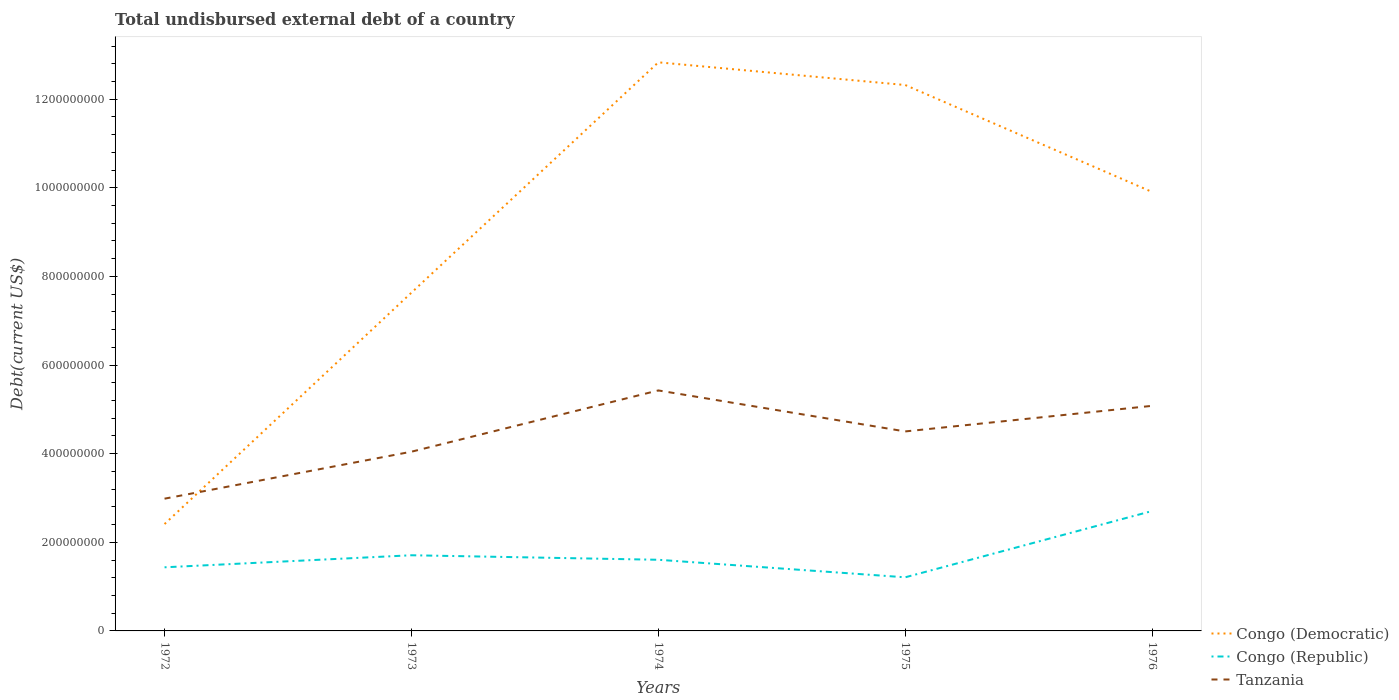How many different coloured lines are there?
Your answer should be compact. 3. Does the line corresponding to Congo (Republic) intersect with the line corresponding to Congo (Democratic)?
Ensure brevity in your answer.  No. Across all years, what is the maximum total undisbursed external debt in Tanzania?
Provide a short and direct response. 2.98e+08. In which year was the total undisbursed external debt in Tanzania maximum?
Your answer should be very brief. 1972. What is the total total undisbursed external debt in Congo (Democratic) in the graph?
Give a very brief answer. -1.04e+09. What is the difference between the highest and the second highest total undisbursed external debt in Tanzania?
Give a very brief answer. 2.44e+08. What is the difference between the highest and the lowest total undisbursed external debt in Congo (Republic)?
Offer a very short reply. 1. Is the total undisbursed external debt in Congo (Democratic) strictly greater than the total undisbursed external debt in Congo (Republic) over the years?
Your response must be concise. No. How many lines are there?
Offer a terse response. 3. Are the values on the major ticks of Y-axis written in scientific E-notation?
Ensure brevity in your answer.  No. Does the graph contain any zero values?
Offer a terse response. No. Where does the legend appear in the graph?
Provide a short and direct response. Bottom right. How many legend labels are there?
Keep it short and to the point. 3. How are the legend labels stacked?
Your answer should be compact. Vertical. What is the title of the graph?
Keep it short and to the point. Total undisbursed external debt of a country. What is the label or title of the X-axis?
Offer a terse response. Years. What is the label or title of the Y-axis?
Provide a succinct answer. Debt(current US$). What is the Debt(current US$) of Congo (Democratic) in 1972?
Your answer should be compact. 2.41e+08. What is the Debt(current US$) in Congo (Republic) in 1972?
Give a very brief answer. 1.44e+08. What is the Debt(current US$) of Tanzania in 1972?
Your answer should be compact. 2.98e+08. What is the Debt(current US$) in Congo (Democratic) in 1973?
Provide a short and direct response. 7.63e+08. What is the Debt(current US$) in Congo (Republic) in 1973?
Offer a terse response. 1.71e+08. What is the Debt(current US$) of Tanzania in 1973?
Offer a terse response. 4.04e+08. What is the Debt(current US$) in Congo (Democratic) in 1974?
Give a very brief answer. 1.28e+09. What is the Debt(current US$) of Congo (Republic) in 1974?
Offer a terse response. 1.61e+08. What is the Debt(current US$) in Tanzania in 1974?
Your answer should be very brief. 5.43e+08. What is the Debt(current US$) of Congo (Democratic) in 1975?
Provide a short and direct response. 1.23e+09. What is the Debt(current US$) in Congo (Republic) in 1975?
Provide a short and direct response. 1.21e+08. What is the Debt(current US$) in Tanzania in 1975?
Provide a short and direct response. 4.50e+08. What is the Debt(current US$) of Congo (Democratic) in 1976?
Offer a very short reply. 9.91e+08. What is the Debt(current US$) of Congo (Republic) in 1976?
Provide a succinct answer. 2.71e+08. What is the Debt(current US$) of Tanzania in 1976?
Keep it short and to the point. 5.08e+08. Across all years, what is the maximum Debt(current US$) of Congo (Democratic)?
Offer a very short reply. 1.28e+09. Across all years, what is the maximum Debt(current US$) in Congo (Republic)?
Provide a succinct answer. 2.71e+08. Across all years, what is the maximum Debt(current US$) in Tanzania?
Ensure brevity in your answer.  5.43e+08. Across all years, what is the minimum Debt(current US$) of Congo (Democratic)?
Give a very brief answer. 2.41e+08. Across all years, what is the minimum Debt(current US$) in Congo (Republic)?
Provide a succinct answer. 1.21e+08. Across all years, what is the minimum Debt(current US$) of Tanzania?
Make the answer very short. 2.98e+08. What is the total Debt(current US$) of Congo (Democratic) in the graph?
Give a very brief answer. 4.51e+09. What is the total Debt(current US$) of Congo (Republic) in the graph?
Give a very brief answer. 8.67e+08. What is the total Debt(current US$) of Tanzania in the graph?
Keep it short and to the point. 2.20e+09. What is the difference between the Debt(current US$) in Congo (Democratic) in 1972 and that in 1973?
Keep it short and to the point. -5.22e+08. What is the difference between the Debt(current US$) of Congo (Republic) in 1972 and that in 1973?
Give a very brief answer. -2.72e+07. What is the difference between the Debt(current US$) in Tanzania in 1972 and that in 1973?
Offer a terse response. -1.06e+08. What is the difference between the Debt(current US$) of Congo (Democratic) in 1972 and that in 1974?
Your answer should be compact. -1.04e+09. What is the difference between the Debt(current US$) of Congo (Republic) in 1972 and that in 1974?
Provide a short and direct response. -1.70e+07. What is the difference between the Debt(current US$) of Tanzania in 1972 and that in 1974?
Ensure brevity in your answer.  -2.44e+08. What is the difference between the Debt(current US$) in Congo (Democratic) in 1972 and that in 1975?
Make the answer very short. -9.91e+08. What is the difference between the Debt(current US$) in Congo (Republic) in 1972 and that in 1975?
Offer a very short reply. 2.26e+07. What is the difference between the Debt(current US$) in Tanzania in 1972 and that in 1975?
Offer a very short reply. -1.52e+08. What is the difference between the Debt(current US$) of Congo (Democratic) in 1972 and that in 1976?
Your response must be concise. -7.49e+08. What is the difference between the Debt(current US$) of Congo (Republic) in 1972 and that in 1976?
Keep it short and to the point. -1.27e+08. What is the difference between the Debt(current US$) of Tanzania in 1972 and that in 1976?
Give a very brief answer. -2.10e+08. What is the difference between the Debt(current US$) in Congo (Democratic) in 1973 and that in 1974?
Offer a terse response. -5.20e+08. What is the difference between the Debt(current US$) in Congo (Republic) in 1973 and that in 1974?
Provide a short and direct response. 1.02e+07. What is the difference between the Debt(current US$) of Tanzania in 1973 and that in 1974?
Your answer should be very brief. -1.38e+08. What is the difference between the Debt(current US$) in Congo (Democratic) in 1973 and that in 1975?
Make the answer very short. -4.69e+08. What is the difference between the Debt(current US$) in Congo (Republic) in 1973 and that in 1975?
Make the answer very short. 4.97e+07. What is the difference between the Debt(current US$) in Tanzania in 1973 and that in 1975?
Your answer should be very brief. -4.58e+07. What is the difference between the Debt(current US$) of Congo (Democratic) in 1973 and that in 1976?
Offer a very short reply. -2.27e+08. What is the difference between the Debt(current US$) in Congo (Republic) in 1973 and that in 1976?
Offer a terse response. -9.98e+07. What is the difference between the Debt(current US$) of Tanzania in 1973 and that in 1976?
Your response must be concise. -1.04e+08. What is the difference between the Debt(current US$) in Congo (Democratic) in 1974 and that in 1975?
Keep it short and to the point. 5.12e+07. What is the difference between the Debt(current US$) in Congo (Republic) in 1974 and that in 1975?
Give a very brief answer. 3.96e+07. What is the difference between the Debt(current US$) in Tanzania in 1974 and that in 1975?
Ensure brevity in your answer.  9.25e+07. What is the difference between the Debt(current US$) in Congo (Democratic) in 1974 and that in 1976?
Give a very brief answer. 2.93e+08. What is the difference between the Debt(current US$) in Congo (Republic) in 1974 and that in 1976?
Provide a short and direct response. -1.10e+08. What is the difference between the Debt(current US$) in Tanzania in 1974 and that in 1976?
Give a very brief answer. 3.48e+07. What is the difference between the Debt(current US$) in Congo (Democratic) in 1975 and that in 1976?
Give a very brief answer. 2.41e+08. What is the difference between the Debt(current US$) in Congo (Republic) in 1975 and that in 1976?
Make the answer very short. -1.50e+08. What is the difference between the Debt(current US$) of Tanzania in 1975 and that in 1976?
Offer a terse response. -5.78e+07. What is the difference between the Debt(current US$) in Congo (Democratic) in 1972 and the Debt(current US$) in Congo (Republic) in 1973?
Give a very brief answer. 7.04e+07. What is the difference between the Debt(current US$) of Congo (Democratic) in 1972 and the Debt(current US$) of Tanzania in 1973?
Keep it short and to the point. -1.63e+08. What is the difference between the Debt(current US$) of Congo (Republic) in 1972 and the Debt(current US$) of Tanzania in 1973?
Your response must be concise. -2.61e+08. What is the difference between the Debt(current US$) of Congo (Democratic) in 1972 and the Debt(current US$) of Congo (Republic) in 1974?
Your response must be concise. 8.06e+07. What is the difference between the Debt(current US$) in Congo (Democratic) in 1972 and the Debt(current US$) in Tanzania in 1974?
Your response must be concise. -3.02e+08. What is the difference between the Debt(current US$) of Congo (Republic) in 1972 and the Debt(current US$) of Tanzania in 1974?
Offer a terse response. -3.99e+08. What is the difference between the Debt(current US$) in Congo (Democratic) in 1972 and the Debt(current US$) in Congo (Republic) in 1975?
Provide a short and direct response. 1.20e+08. What is the difference between the Debt(current US$) in Congo (Democratic) in 1972 and the Debt(current US$) in Tanzania in 1975?
Give a very brief answer. -2.09e+08. What is the difference between the Debt(current US$) in Congo (Republic) in 1972 and the Debt(current US$) in Tanzania in 1975?
Your answer should be very brief. -3.07e+08. What is the difference between the Debt(current US$) of Congo (Democratic) in 1972 and the Debt(current US$) of Congo (Republic) in 1976?
Ensure brevity in your answer.  -2.94e+07. What is the difference between the Debt(current US$) of Congo (Democratic) in 1972 and the Debt(current US$) of Tanzania in 1976?
Your response must be concise. -2.67e+08. What is the difference between the Debt(current US$) of Congo (Republic) in 1972 and the Debt(current US$) of Tanzania in 1976?
Ensure brevity in your answer.  -3.64e+08. What is the difference between the Debt(current US$) of Congo (Democratic) in 1973 and the Debt(current US$) of Congo (Republic) in 1974?
Offer a very short reply. 6.03e+08. What is the difference between the Debt(current US$) in Congo (Democratic) in 1973 and the Debt(current US$) in Tanzania in 1974?
Offer a very short reply. 2.21e+08. What is the difference between the Debt(current US$) of Congo (Republic) in 1973 and the Debt(current US$) of Tanzania in 1974?
Make the answer very short. -3.72e+08. What is the difference between the Debt(current US$) in Congo (Democratic) in 1973 and the Debt(current US$) in Congo (Republic) in 1975?
Your answer should be very brief. 6.42e+08. What is the difference between the Debt(current US$) of Congo (Democratic) in 1973 and the Debt(current US$) of Tanzania in 1975?
Ensure brevity in your answer.  3.13e+08. What is the difference between the Debt(current US$) of Congo (Republic) in 1973 and the Debt(current US$) of Tanzania in 1975?
Offer a terse response. -2.79e+08. What is the difference between the Debt(current US$) in Congo (Democratic) in 1973 and the Debt(current US$) in Congo (Republic) in 1976?
Provide a succinct answer. 4.93e+08. What is the difference between the Debt(current US$) in Congo (Democratic) in 1973 and the Debt(current US$) in Tanzania in 1976?
Offer a terse response. 2.55e+08. What is the difference between the Debt(current US$) in Congo (Republic) in 1973 and the Debt(current US$) in Tanzania in 1976?
Offer a terse response. -3.37e+08. What is the difference between the Debt(current US$) of Congo (Democratic) in 1974 and the Debt(current US$) of Congo (Republic) in 1975?
Your response must be concise. 1.16e+09. What is the difference between the Debt(current US$) in Congo (Democratic) in 1974 and the Debt(current US$) in Tanzania in 1975?
Keep it short and to the point. 8.33e+08. What is the difference between the Debt(current US$) of Congo (Republic) in 1974 and the Debt(current US$) of Tanzania in 1975?
Keep it short and to the point. -2.90e+08. What is the difference between the Debt(current US$) in Congo (Democratic) in 1974 and the Debt(current US$) in Congo (Republic) in 1976?
Your answer should be compact. 1.01e+09. What is the difference between the Debt(current US$) of Congo (Democratic) in 1974 and the Debt(current US$) of Tanzania in 1976?
Your answer should be compact. 7.75e+08. What is the difference between the Debt(current US$) in Congo (Republic) in 1974 and the Debt(current US$) in Tanzania in 1976?
Your answer should be compact. -3.47e+08. What is the difference between the Debt(current US$) of Congo (Democratic) in 1975 and the Debt(current US$) of Congo (Republic) in 1976?
Provide a short and direct response. 9.61e+08. What is the difference between the Debt(current US$) of Congo (Democratic) in 1975 and the Debt(current US$) of Tanzania in 1976?
Ensure brevity in your answer.  7.24e+08. What is the difference between the Debt(current US$) in Congo (Republic) in 1975 and the Debt(current US$) in Tanzania in 1976?
Offer a terse response. -3.87e+08. What is the average Debt(current US$) in Congo (Democratic) per year?
Keep it short and to the point. 9.02e+08. What is the average Debt(current US$) in Congo (Republic) per year?
Your answer should be very brief. 1.73e+08. What is the average Debt(current US$) of Tanzania per year?
Your response must be concise. 4.41e+08. In the year 1972, what is the difference between the Debt(current US$) in Congo (Democratic) and Debt(current US$) in Congo (Republic)?
Offer a very short reply. 9.76e+07. In the year 1972, what is the difference between the Debt(current US$) of Congo (Democratic) and Debt(current US$) of Tanzania?
Ensure brevity in your answer.  -5.73e+07. In the year 1972, what is the difference between the Debt(current US$) in Congo (Republic) and Debt(current US$) in Tanzania?
Your answer should be compact. -1.55e+08. In the year 1973, what is the difference between the Debt(current US$) in Congo (Democratic) and Debt(current US$) in Congo (Republic)?
Make the answer very short. 5.93e+08. In the year 1973, what is the difference between the Debt(current US$) of Congo (Democratic) and Debt(current US$) of Tanzania?
Offer a very short reply. 3.59e+08. In the year 1973, what is the difference between the Debt(current US$) in Congo (Republic) and Debt(current US$) in Tanzania?
Your answer should be compact. -2.34e+08. In the year 1974, what is the difference between the Debt(current US$) of Congo (Democratic) and Debt(current US$) of Congo (Republic)?
Give a very brief answer. 1.12e+09. In the year 1974, what is the difference between the Debt(current US$) in Congo (Democratic) and Debt(current US$) in Tanzania?
Give a very brief answer. 7.40e+08. In the year 1974, what is the difference between the Debt(current US$) of Congo (Republic) and Debt(current US$) of Tanzania?
Make the answer very short. -3.82e+08. In the year 1975, what is the difference between the Debt(current US$) in Congo (Democratic) and Debt(current US$) in Congo (Republic)?
Provide a short and direct response. 1.11e+09. In the year 1975, what is the difference between the Debt(current US$) in Congo (Democratic) and Debt(current US$) in Tanzania?
Your response must be concise. 7.82e+08. In the year 1975, what is the difference between the Debt(current US$) of Congo (Republic) and Debt(current US$) of Tanzania?
Your answer should be compact. -3.29e+08. In the year 1976, what is the difference between the Debt(current US$) of Congo (Democratic) and Debt(current US$) of Congo (Republic)?
Offer a very short reply. 7.20e+08. In the year 1976, what is the difference between the Debt(current US$) of Congo (Democratic) and Debt(current US$) of Tanzania?
Your answer should be compact. 4.83e+08. In the year 1976, what is the difference between the Debt(current US$) in Congo (Republic) and Debt(current US$) in Tanzania?
Make the answer very short. -2.37e+08. What is the ratio of the Debt(current US$) of Congo (Democratic) in 1972 to that in 1973?
Provide a short and direct response. 0.32. What is the ratio of the Debt(current US$) of Congo (Republic) in 1972 to that in 1973?
Ensure brevity in your answer.  0.84. What is the ratio of the Debt(current US$) in Tanzania in 1972 to that in 1973?
Your response must be concise. 0.74. What is the ratio of the Debt(current US$) in Congo (Democratic) in 1972 to that in 1974?
Give a very brief answer. 0.19. What is the ratio of the Debt(current US$) in Congo (Republic) in 1972 to that in 1974?
Offer a very short reply. 0.89. What is the ratio of the Debt(current US$) in Tanzania in 1972 to that in 1974?
Ensure brevity in your answer.  0.55. What is the ratio of the Debt(current US$) of Congo (Democratic) in 1972 to that in 1975?
Your answer should be compact. 0.2. What is the ratio of the Debt(current US$) of Congo (Republic) in 1972 to that in 1975?
Your response must be concise. 1.19. What is the ratio of the Debt(current US$) of Tanzania in 1972 to that in 1975?
Provide a short and direct response. 0.66. What is the ratio of the Debt(current US$) in Congo (Democratic) in 1972 to that in 1976?
Make the answer very short. 0.24. What is the ratio of the Debt(current US$) in Congo (Republic) in 1972 to that in 1976?
Provide a succinct answer. 0.53. What is the ratio of the Debt(current US$) in Tanzania in 1972 to that in 1976?
Offer a terse response. 0.59. What is the ratio of the Debt(current US$) of Congo (Democratic) in 1973 to that in 1974?
Your answer should be very brief. 0.59. What is the ratio of the Debt(current US$) of Congo (Republic) in 1973 to that in 1974?
Offer a very short reply. 1.06. What is the ratio of the Debt(current US$) in Tanzania in 1973 to that in 1974?
Your answer should be very brief. 0.75. What is the ratio of the Debt(current US$) of Congo (Democratic) in 1973 to that in 1975?
Your answer should be compact. 0.62. What is the ratio of the Debt(current US$) in Congo (Republic) in 1973 to that in 1975?
Provide a succinct answer. 1.41. What is the ratio of the Debt(current US$) in Tanzania in 1973 to that in 1975?
Ensure brevity in your answer.  0.9. What is the ratio of the Debt(current US$) in Congo (Democratic) in 1973 to that in 1976?
Make the answer very short. 0.77. What is the ratio of the Debt(current US$) of Congo (Republic) in 1973 to that in 1976?
Offer a terse response. 0.63. What is the ratio of the Debt(current US$) in Tanzania in 1973 to that in 1976?
Your answer should be very brief. 0.8. What is the ratio of the Debt(current US$) of Congo (Democratic) in 1974 to that in 1975?
Offer a very short reply. 1.04. What is the ratio of the Debt(current US$) of Congo (Republic) in 1974 to that in 1975?
Your answer should be compact. 1.33. What is the ratio of the Debt(current US$) in Tanzania in 1974 to that in 1975?
Your answer should be very brief. 1.21. What is the ratio of the Debt(current US$) in Congo (Democratic) in 1974 to that in 1976?
Offer a very short reply. 1.3. What is the ratio of the Debt(current US$) of Congo (Republic) in 1974 to that in 1976?
Your answer should be very brief. 0.59. What is the ratio of the Debt(current US$) of Tanzania in 1974 to that in 1976?
Offer a very short reply. 1.07. What is the ratio of the Debt(current US$) in Congo (Democratic) in 1975 to that in 1976?
Your response must be concise. 1.24. What is the ratio of the Debt(current US$) in Congo (Republic) in 1975 to that in 1976?
Your response must be concise. 0.45. What is the ratio of the Debt(current US$) in Tanzania in 1975 to that in 1976?
Provide a succinct answer. 0.89. What is the difference between the highest and the second highest Debt(current US$) in Congo (Democratic)?
Provide a short and direct response. 5.12e+07. What is the difference between the highest and the second highest Debt(current US$) of Congo (Republic)?
Your answer should be very brief. 9.98e+07. What is the difference between the highest and the second highest Debt(current US$) in Tanzania?
Offer a terse response. 3.48e+07. What is the difference between the highest and the lowest Debt(current US$) of Congo (Democratic)?
Give a very brief answer. 1.04e+09. What is the difference between the highest and the lowest Debt(current US$) of Congo (Republic)?
Your answer should be very brief. 1.50e+08. What is the difference between the highest and the lowest Debt(current US$) of Tanzania?
Offer a terse response. 2.44e+08. 